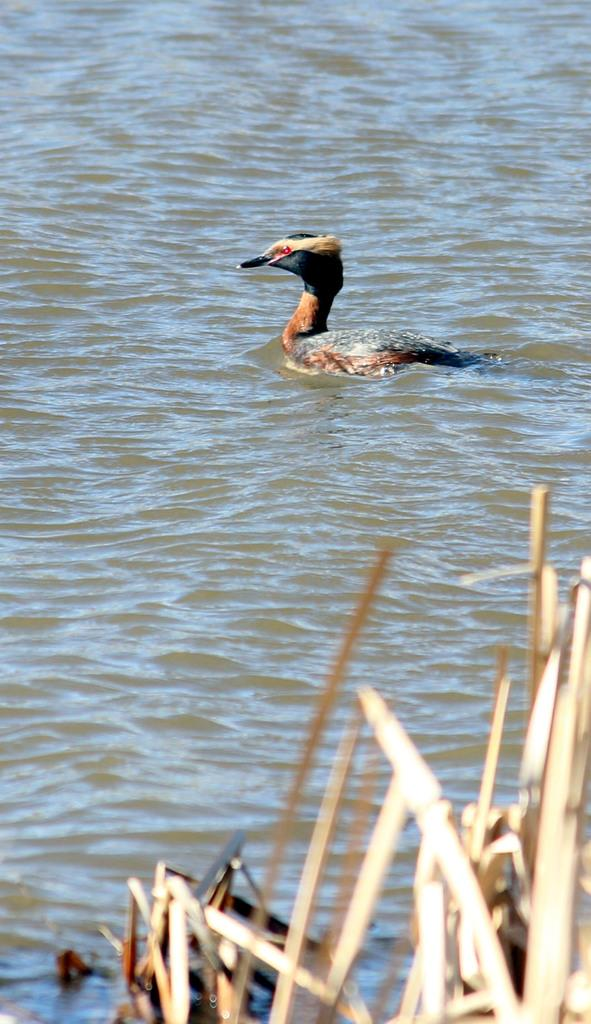What is present in the image that is not a solid object? There is water visible in the image. What type of animal can be seen in the image? There is a bird in the image. Can you describe any other elements in the image? There are objects in the image. How many cherries are floating on the water in the image? There are no cherries present in the image. What time of day is it in the image, given the presence of a sail? There is no sail present in the image, so it is not possible to determine the time of day based on that information. 